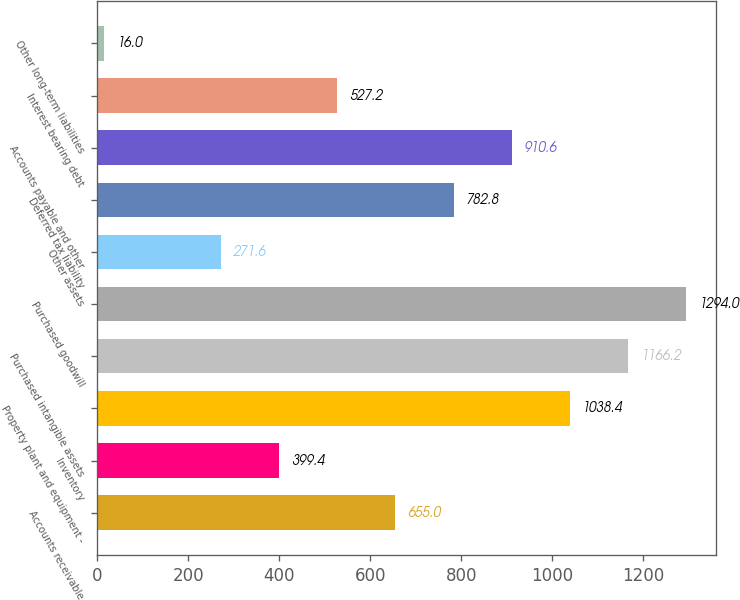<chart> <loc_0><loc_0><loc_500><loc_500><bar_chart><fcel>Accounts receivable<fcel>Inventory<fcel>Property plant and equipment -<fcel>Purchased intangible assets<fcel>Purchased goodwill<fcel>Other assets<fcel>Deferred tax liability<fcel>Accounts payable and other<fcel>Interest bearing debt<fcel>Other long-term liabilities<nl><fcel>655<fcel>399.4<fcel>1038.4<fcel>1166.2<fcel>1294<fcel>271.6<fcel>782.8<fcel>910.6<fcel>527.2<fcel>16<nl></chart> 